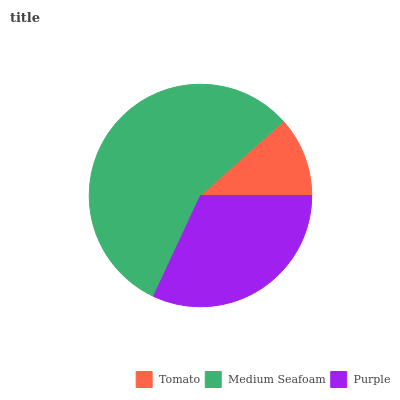Is Tomato the minimum?
Answer yes or no. Yes. Is Medium Seafoam the maximum?
Answer yes or no. Yes. Is Purple the minimum?
Answer yes or no. No. Is Purple the maximum?
Answer yes or no. No. Is Medium Seafoam greater than Purple?
Answer yes or no. Yes. Is Purple less than Medium Seafoam?
Answer yes or no. Yes. Is Purple greater than Medium Seafoam?
Answer yes or no. No. Is Medium Seafoam less than Purple?
Answer yes or no. No. Is Purple the high median?
Answer yes or no. Yes. Is Purple the low median?
Answer yes or no. Yes. Is Medium Seafoam the high median?
Answer yes or no. No. Is Medium Seafoam the low median?
Answer yes or no. No. 